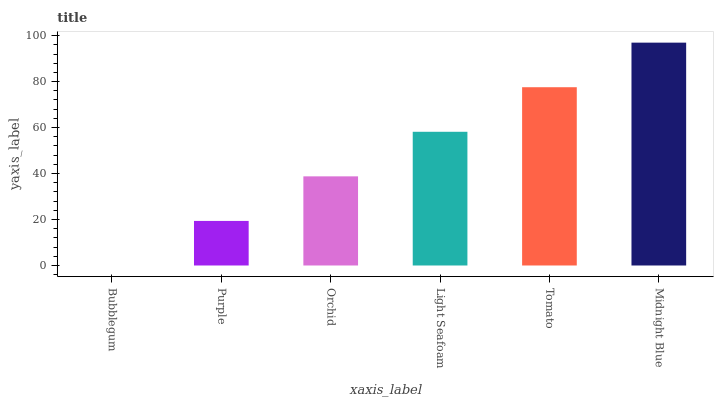Is Bubblegum the minimum?
Answer yes or no. Yes. Is Midnight Blue the maximum?
Answer yes or no. Yes. Is Purple the minimum?
Answer yes or no. No. Is Purple the maximum?
Answer yes or no. No. Is Purple greater than Bubblegum?
Answer yes or no. Yes. Is Bubblegum less than Purple?
Answer yes or no. Yes. Is Bubblegum greater than Purple?
Answer yes or no. No. Is Purple less than Bubblegum?
Answer yes or no. No. Is Light Seafoam the high median?
Answer yes or no. Yes. Is Orchid the low median?
Answer yes or no. Yes. Is Tomato the high median?
Answer yes or no. No. Is Tomato the low median?
Answer yes or no. No. 